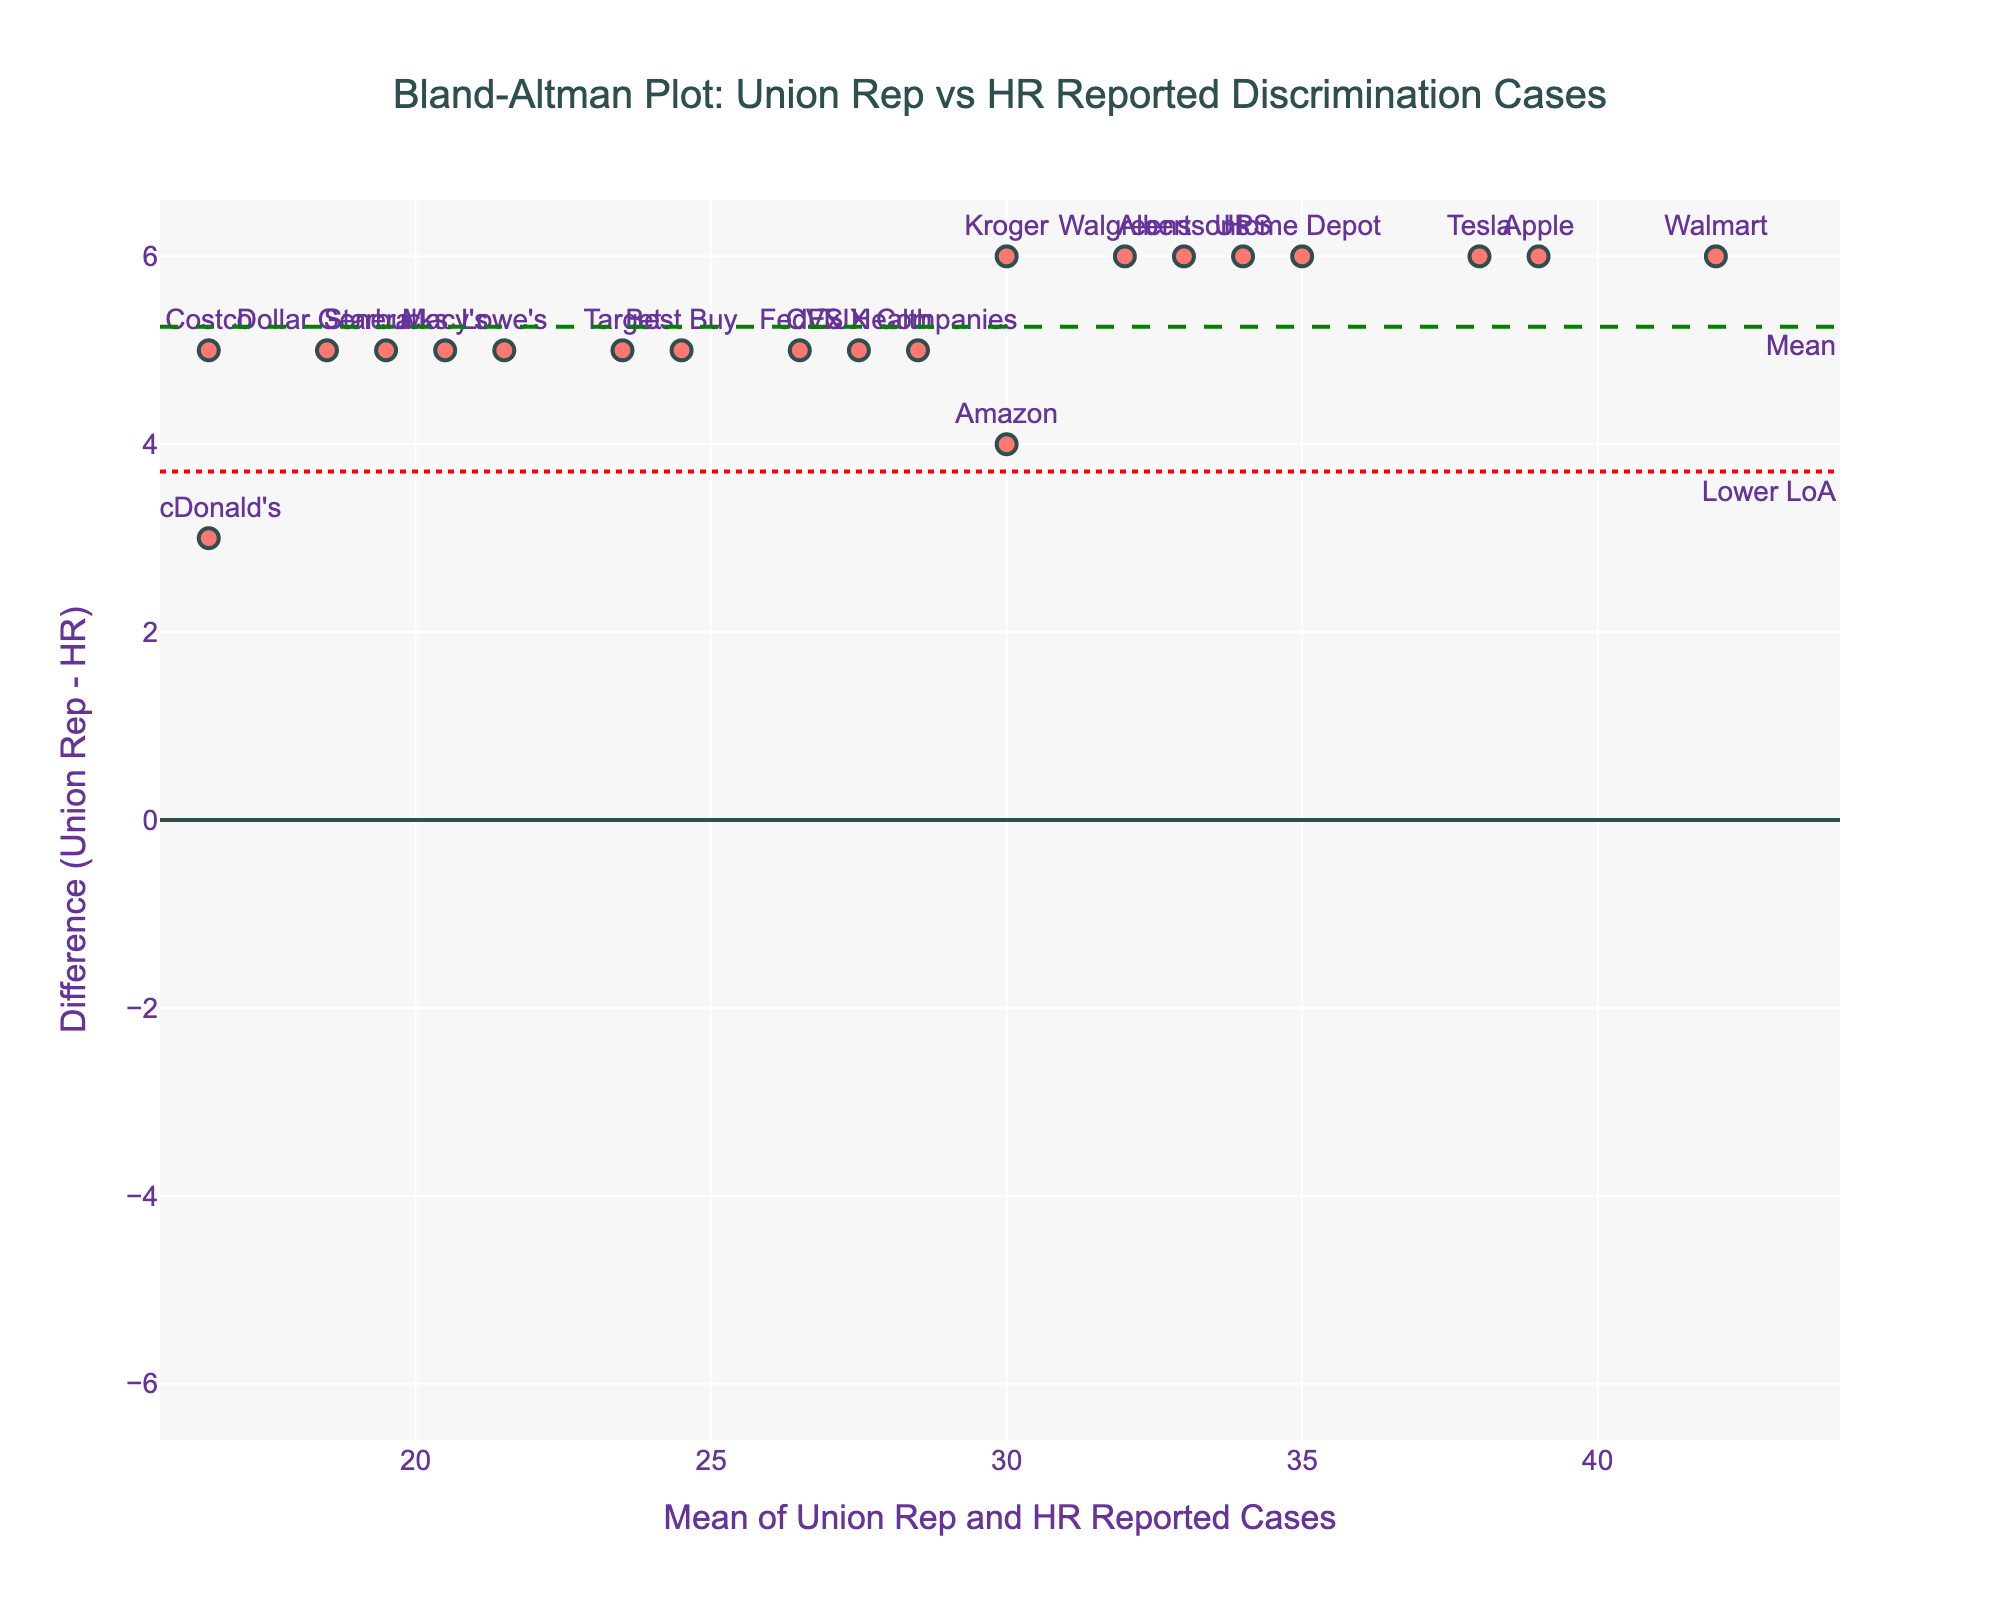What does the dashed green line represent in the plot? The dashed green line represents the mean difference between the numbers of discrimination cases reported by Union Representatives and Human Resources. In a Bland-Altman plot, this line helps visualize the average bias between the two sets of reports.
Answer: The mean difference How many companies have data points above the upper limit of agreement (Upper LoA)? By looking at the data points and checking which ones are above the dotted red line, one can count the specific number of companies. The upper limit of agreement usually signifies an extreme discrepancy.
Answer: None Which company showed the largest positive difference between Union Representative and HR reported cases? By identifying the company name associated with the highest data point on the y-axis of the plot, we can determine the company with the largest positive difference.
Answer: Apple What is the difference in reported cases between Union Reps and HR for Walmart? The y-coordinate value labeled as “Walmart” represents this difference in the plot.
Answer: 6 Compare the mean difference line with the upper and lower limits of agreement. Are they equidistant from the mean line? Calculating the distance of each agreement limit from the mean line will show if the distances are equal, suggesting symmetric agreement intervals.
Answer: Yes, they are equidistant What is the range of the differences represented on the y-axis? Find the minimum and maximum y-values on the plot to determine the range, which spans the vertical axis from the lowest to the highest differences.
Answer: -5 to 7 Which company is closest to the mean difference line? By spotting the data point nearest to the dashed green mean line, you find the company that has a difference close to the mean.
Answer: CVS Health What does a data point below the mean difference line indicate? A point below the mean line suggests that the number of cases reported by Union Representatives is fewer than those reported by HR, as the difference (Union Rep - HR) is negative.
Answer: Union reported fewer cases Are there any companies where the Union Representative and HR reported the same number of discrimination cases? By checking if any data points lie on the horizontal line at y=0, it indicates equal reporting by both.
Answer: No What does the spread of data points around the mean difference line suggest about the agreement between Union Reps and HR on discrimination reports? The spread indicates the variability or agreement level. A narrow spread suggests high agreement, while a wide spread indicates more discrepancies.
Answer: Moderate agreement 